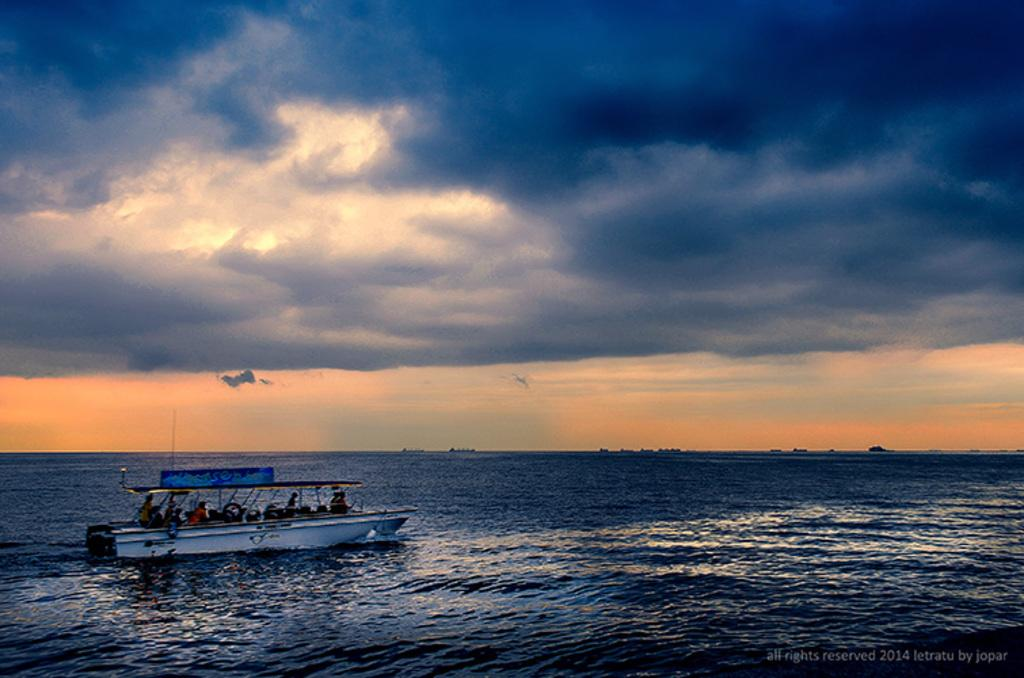What is the main subject in the foreground of the image? There is a boat in the foreground of the image. Where is the boat located? The boat is on the water. What can be seen at the top of the image? The sky is visible at the top of the image. What is the condition of the sky in the image? There are clouds in the sky. What type of mint is growing near the boat in the image? There is no mint present in the image; it features a boat on the water with a cloudy sky. 